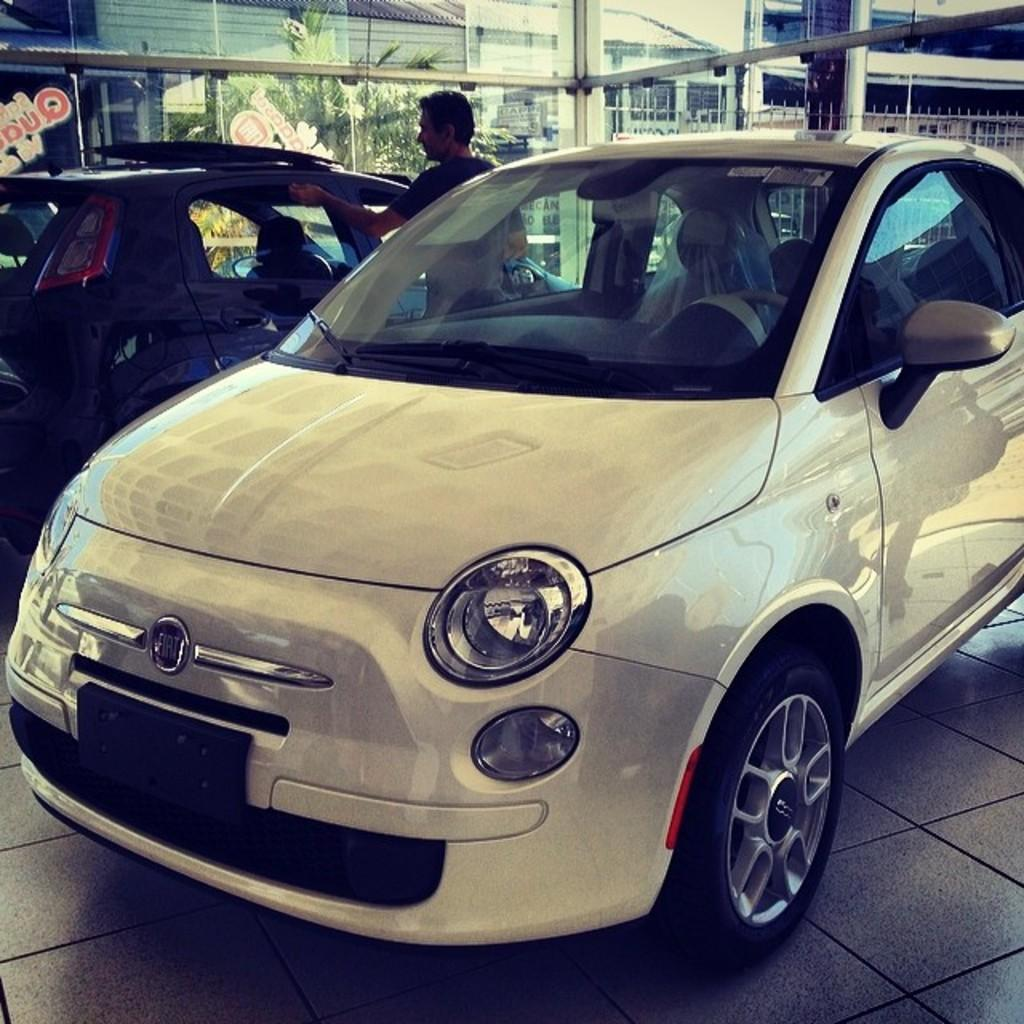How many cars are in the image? There are two cars in the image. What else can be seen in the image besides the cars? There is a person standing in the image. What can be seen in the background of the image? There are buildings, a tree, and other objects visible in the background of the image. What type of form does the railway take in the image? There is no railway present in the image. 